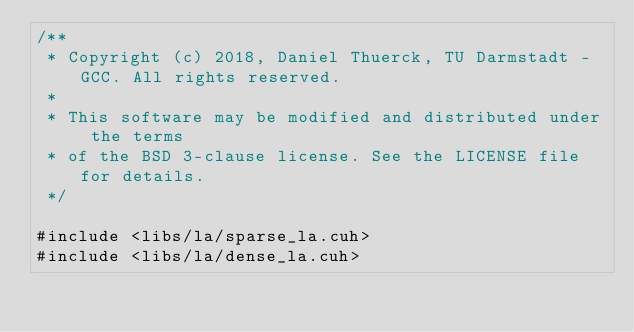Convert code to text. <code><loc_0><loc_0><loc_500><loc_500><_Cuda_>/**
 * Copyright (c) 2018, Daniel Thuerck, TU Darmstadt - GCC. All rights reserved.
 *
 * This software may be modified and distributed under the terms
 * of the BSD 3-clause license. See the LICENSE file for details.
 */

#include <libs/la/sparse_la.cuh>
#include <libs/la/dense_la.cuh></code> 